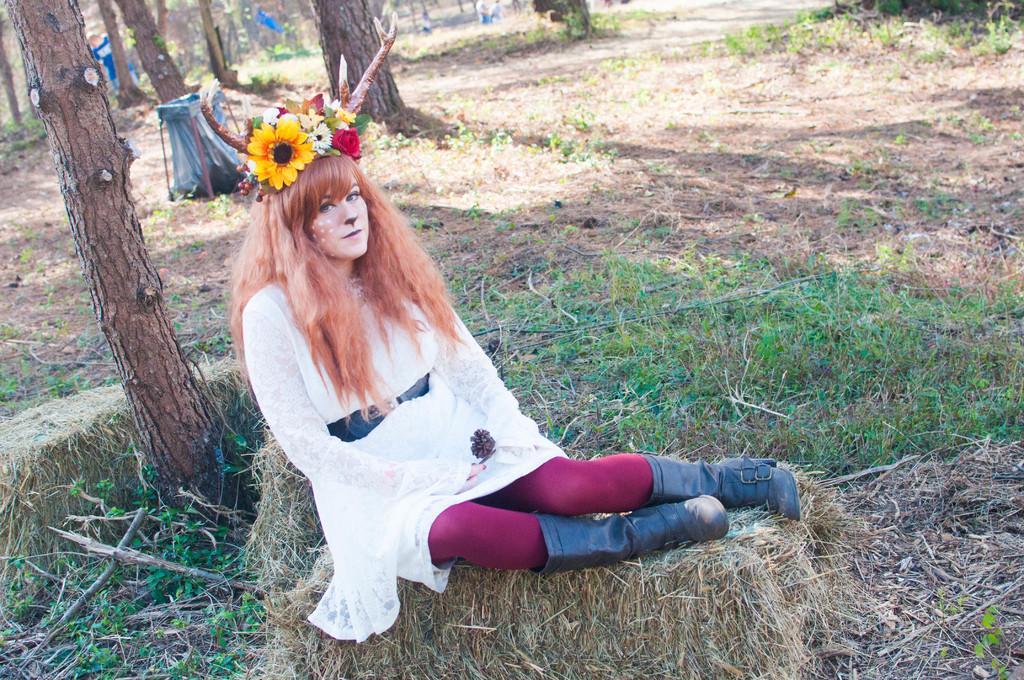In one or two sentences, can you explain what this image depicts? In this image I can see a woman sitting on the grass. On the left side I can see the trees. 